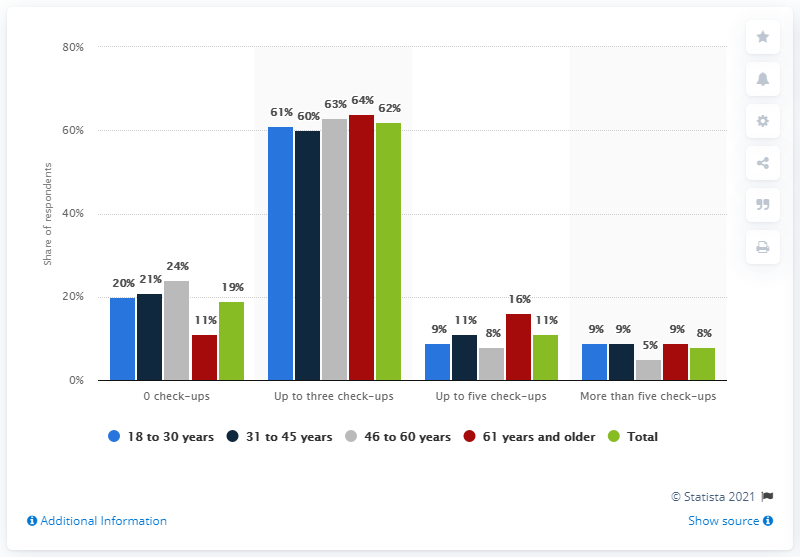Draw attention to some important aspects in this diagram. The difference between the highest and the lowest green bar is 54. The difference between the highest and the lowest dark blue bar is 51... 